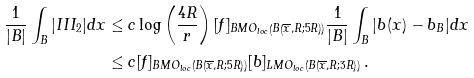Convert formula to latex. <formula><loc_0><loc_0><loc_500><loc_500>\frac { 1 } { | B | } \int _ { B } | I I I _ { 2 } | d x & \leq c \log \left ( \frac { 4 R } { r } \right ) [ f ] _ { B M O _ { l o c } \left ( B \left ( \overline { x } , R ; 5 R \right ) \right ) } \frac { 1 } { | B | } \int _ { B } | b ( x ) - b _ { B } | d x \\ & \leq c [ f ] _ { B M O _ { l o c } \left ( B \left ( \overline { x } , R ; 5 R \right ) \right ) } [ b ] _ { L M O _ { l o c } \left ( B \left ( \overline { x } , R ; 3 R \right ) \right ) } \, .</formula> 